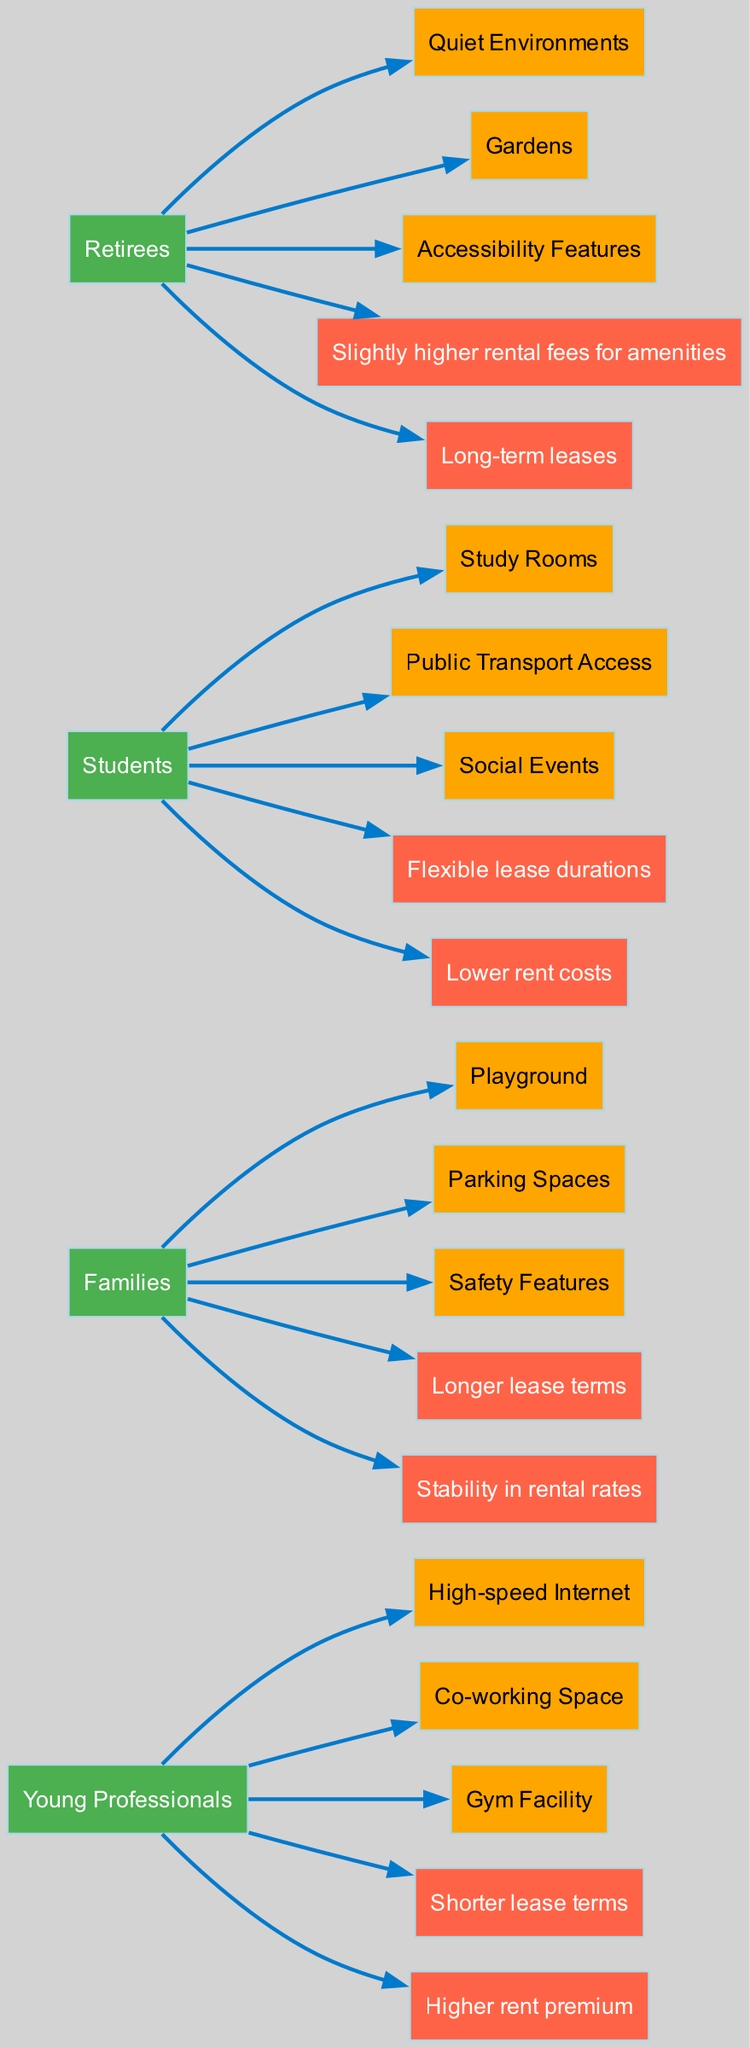What are the most popular amenities requested by families? The diagram shows that families request amenities such as Playground, Parking Spaces, and Safety Features. By looking at the connections from the "Families" node to these amenities, we can clearly identify them.
Answer: Playground, Parking Spaces, Safety Features How many tenant types are represented in the diagram? The diagram includes four nodes for tenant types: Young Professionals, Families, Students, and Retirees. Counting these gives us a total of four tenant types.
Answer: 4 Which tenant type is associated with "Flexible lease durations"? By examining the flows originating from the nodes, we see that "Flexible lease durations" is linked to the "Students" node. Thus, students are the tenant type associated with this impact on leases.
Answer: Students What is the primary impact on lease agreements for young professionals? The diagram indicates that Young Professionals have shorter lease terms and a higher rent premium. Focusing on the flows from the "Young Professionals" node, we can identify that the primary impacts include these two aspects.
Answer: Shorter lease terms Which amenity is specifically requested by retirees? According to the diagram, retirees request Accessibility Features, Quiet Environments, and Gardens. Out of these, "Accessibility Features" is directly linked to the "Retirees" node, indicating its specific request.
Answer: Accessibility Features What common impact do families and retirees share regarding lease agreements? By analyzing the impacts flowing from both the "Families" and "Retirees" nodes, we can see that both tenant types are associated with longer lease terms. Hence, this is a common impact they share.
Answer: Longer lease terms How many edges connect tenants to amenities? There are 12 connections (or edges) that link tenant types to specific amenities as visible through the counts of connections from each tenant node to its respective amenities.
Answer: 12 What is the unique impact on lease agreements for students compared to other tenant types? Examining the impacts flowing from the "Students" node, we can find that they have "Flexible lease durations" and "Lower rent costs," which differentiates them from other tenant types who have different impacts on leases.
Answer: Flexible lease durations, Lower rent costs 